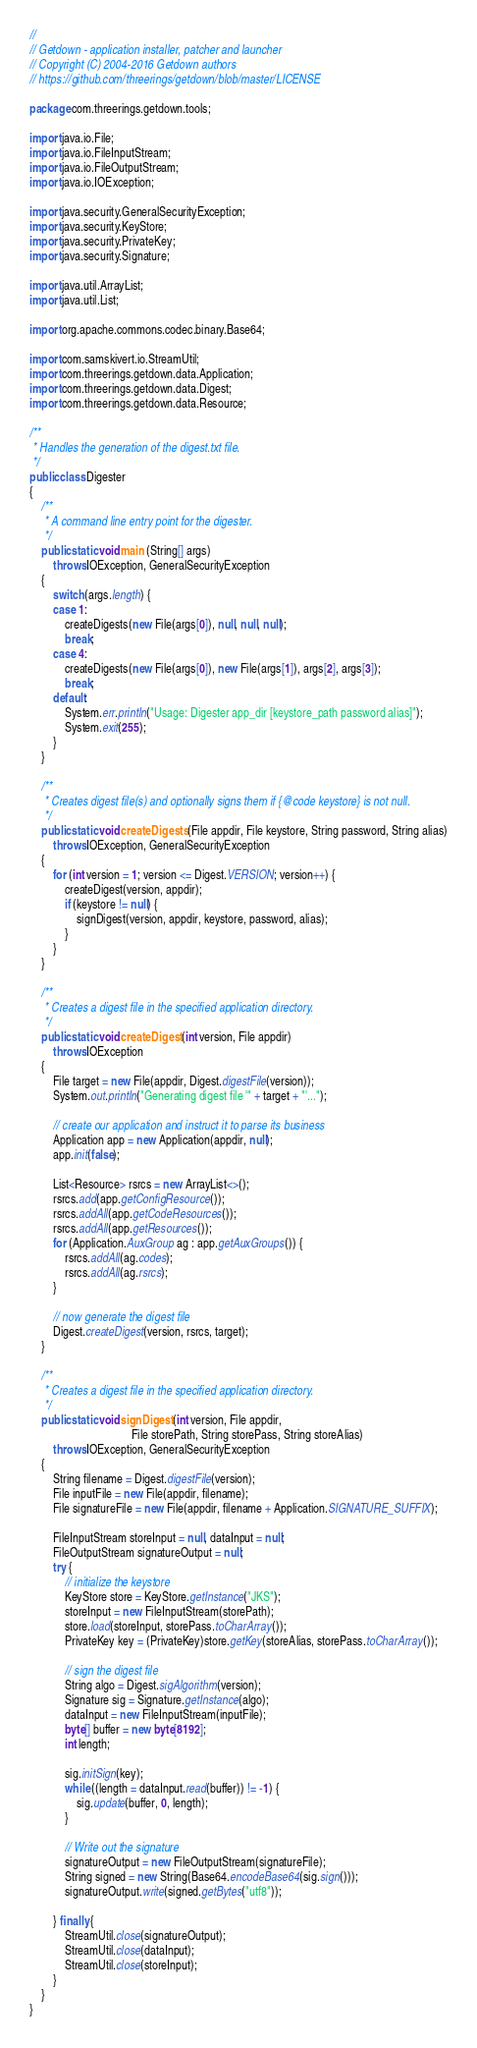Convert code to text. <code><loc_0><loc_0><loc_500><loc_500><_Java_>//
// Getdown - application installer, patcher and launcher
// Copyright (C) 2004-2016 Getdown authors
// https://github.com/threerings/getdown/blob/master/LICENSE

package com.threerings.getdown.tools;

import java.io.File;
import java.io.FileInputStream;
import java.io.FileOutputStream;
import java.io.IOException;

import java.security.GeneralSecurityException;
import java.security.KeyStore;
import java.security.PrivateKey;
import java.security.Signature;

import java.util.ArrayList;
import java.util.List;

import org.apache.commons.codec.binary.Base64;

import com.samskivert.io.StreamUtil;
import com.threerings.getdown.data.Application;
import com.threerings.getdown.data.Digest;
import com.threerings.getdown.data.Resource;

/**
 * Handles the generation of the digest.txt file.
 */
public class Digester
{
    /**
     * A command line entry point for the digester.
     */
    public static void main (String[] args)
        throws IOException, GeneralSecurityException
    {
        switch (args.length) {
        case 1:
            createDigests(new File(args[0]), null, null, null);
            break;
        case 4:
            createDigests(new File(args[0]), new File(args[1]), args[2], args[3]);
            break;
        default:
            System.err.println("Usage: Digester app_dir [keystore_path password alias]");
            System.exit(255);
        }
    }

    /**
     * Creates digest file(s) and optionally signs them if {@code keystore} is not null.
     */
    public static void createDigests (File appdir, File keystore, String password, String alias)
        throws IOException, GeneralSecurityException
    {
        for (int version = 1; version <= Digest.VERSION; version++) {
            createDigest(version, appdir);
            if (keystore != null) {
                signDigest(version, appdir, keystore, password, alias);
            }
        }
    }

    /**
     * Creates a digest file in the specified application directory.
     */
    public static void createDigest (int version, File appdir)
        throws IOException
    {
        File target = new File(appdir, Digest.digestFile(version));
        System.out.println("Generating digest file '" + target + "'...");

        // create our application and instruct it to parse its business
        Application app = new Application(appdir, null);
        app.init(false);

        List<Resource> rsrcs = new ArrayList<>();
        rsrcs.add(app.getConfigResource());
        rsrcs.addAll(app.getCodeResources());
        rsrcs.addAll(app.getResources());
        for (Application.AuxGroup ag : app.getAuxGroups()) {
            rsrcs.addAll(ag.codes);
            rsrcs.addAll(ag.rsrcs);
        }

        // now generate the digest file
        Digest.createDigest(version, rsrcs, target);
    }

    /**
     * Creates a digest file in the specified application directory.
     */
    public static void signDigest (int version, File appdir,
                                   File storePath, String storePass, String storeAlias)
        throws IOException, GeneralSecurityException
    {
        String filename = Digest.digestFile(version);
        File inputFile = new File(appdir, filename);
        File signatureFile = new File(appdir, filename + Application.SIGNATURE_SUFFIX);

        FileInputStream storeInput = null, dataInput = null;
        FileOutputStream signatureOutput = null;
        try {
            // initialize the keystore
            KeyStore store = KeyStore.getInstance("JKS");
            storeInput = new FileInputStream(storePath);
            store.load(storeInput, storePass.toCharArray());
            PrivateKey key = (PrivateKey)store.getKey(storeAlias, storePass.toCharArray());

            // sign the digest file
            String algo = Digest.sigAlgorithm(version);
            Signature sig = Signature.getInstance(algo);
            dataInput = new FileInputStream(inputFile);
            byte[] buffer = new byte[8192];
            int length;

            sig.initSign(key);
            while ((length = dataInput.read(buffer)) != -1) {
                sig.update(buffer, 0, length);
            }

            // Write out the signature
            signatureOutput = new FileOutputStream(signatureFile);
            String signed = new String(Base64.encodeBase64(sig.sign()));
            signatureOutput.write(signed.getBytes("utf8"));

        } finally {
            StreamUtil.close(signatureOutput);
            StreamUtil.close(dataInput);
            StreamUtil.close(storeInput);
        }
    }
}
</code> 